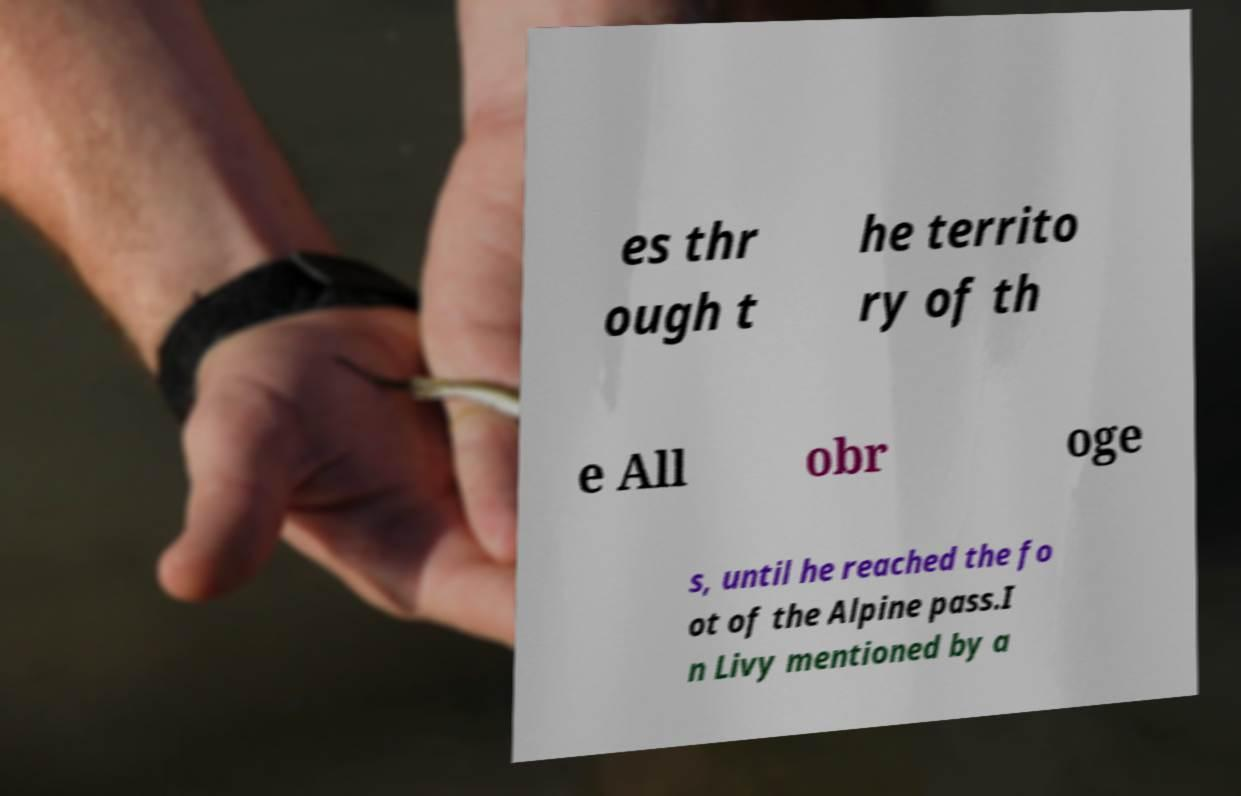What messages or text are displayed in this image? I need them in a readable, typed format. es thr ough t he territo ry of th e All obr oge s, until he reached the fo ot of the Alpine pass.I n Livy mentioned by a 